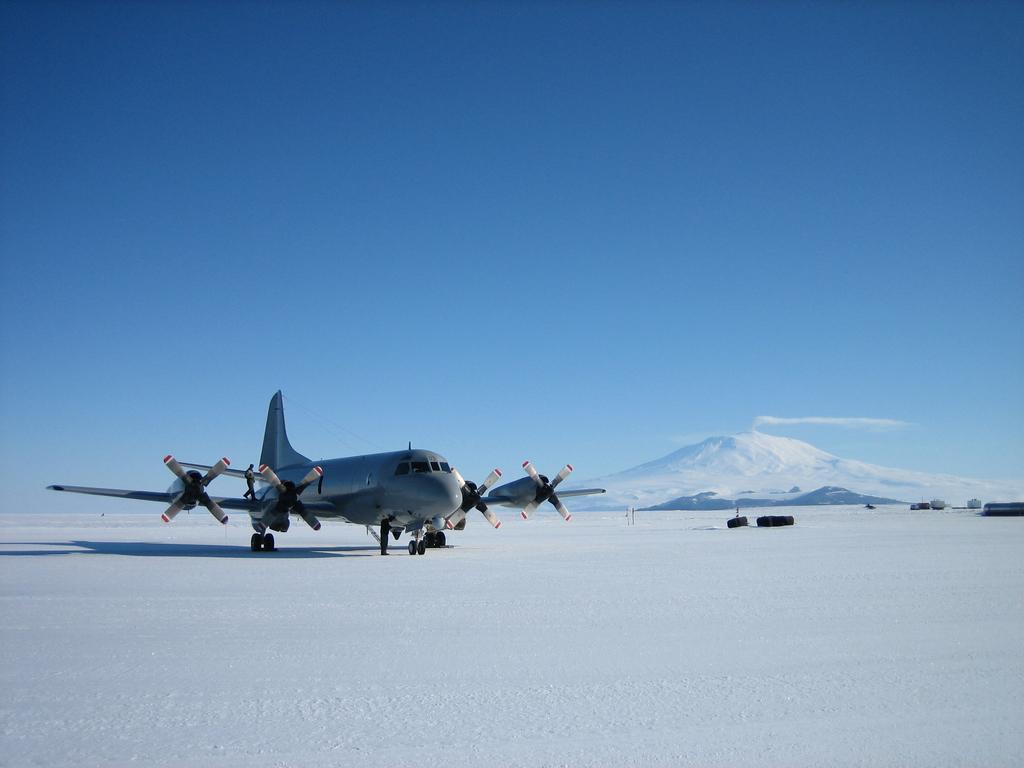Describe this image in one or two sentences. This is an outside view. At the bottom, I can see the snow. On the left side there is an aeroplane on the ground. In the background there is a mountain. At the top of the image I can see the sky in blue color. 